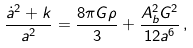<formula> <loc_0><loc_0><loc_500><loc_500>\frac { \dot { a } ^ { 2 } + k } { a ^ { 2 } } = \frac { 8 \pi G \rho } { 3 } + \frac { A _ { b } ^ { 2 } G ^ { 2 } } { 1 2 a ^ { 6 } } \, ,</formula> 